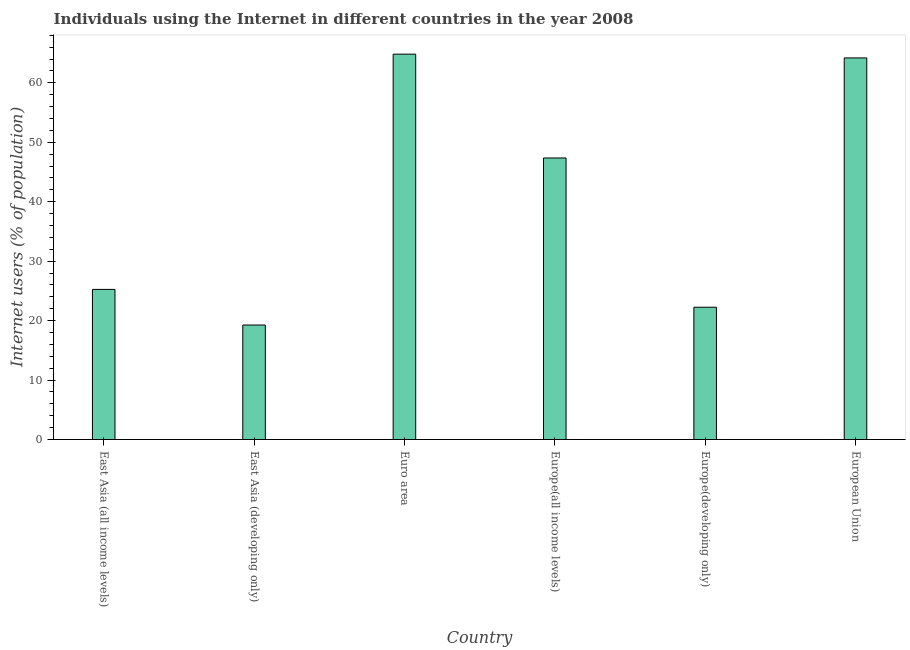Does the graph contain any zero values?
Your response must be concise. No. Does the graph contain grids?
Ensure brevity in your answer.  No. What is the title of the graph?
Ensure brevity in your answer.  Individuals using the Internet in different countries in the year 2008. What is the label or title of the X-axis?
Offer a very short reply. Country. What is the label or title of the Y-axis?
Provide a short and direct response. Internet users (% of population). What is the number of internet users in Euro area?
Give a very brief answer. 64.82. Across all countries, what is the maximum number of internet users?
Offer a terse response. 64.82. Across all countries, what is the minimum number of internet users?
Your answer should be very brief. 19.26. In which country was the number of internet users maximum?
Your response must be concise. Euro area. In which country was the number of internet users minimum?
Your answer should be compact. East Asia (developing only). What is the sum of the number of internet users?
Keep it short and to the point. 243.14. What is the difference between the number of internet users in Europe(developing only) and European Union?
Keep it short and to the point. -41.94. What is the average number of internet users per country?
Give a very brief answer. 40.52. What is the median number of internet users?
Keep it short and to the point. 36.3. In how many countries, is the number of internet users greater than 56 %?
Offer a terse response. 2. What is the ratio of the number of internet users in East Asia (all income levels) to that in Euro area?
Provide a short and direct response. 0.39. Is the number of internet users in Euro area less than that in European Union?
Offer a very short reply. No. Is the difference between the number of internet users in Europe(all income levels) and European Union greater than the difference between any two countries?
Make the answer very short. No. What is the difference between the highest and the second highest number of internet users?
Your response must be concise. 0.64. What is the difference between the highest and the lowest number of internet users?
Keep it short and to the point. 45.56. How many countries are there in the graph?
Your answer should be compact. 6. What is the difference between two consecutive major ticks on the Y-axis?
Ensure brevity in your answer.  10. Are the values on the major ticks of Y-axis written in scientific E-notation?
Offer a very short reply. No. What is the Internet users (% of population) in East Asia (all income levels)?
Your answer should be very brief. 25.25. What is the Internet users (% of population) of East Asia (developing only)?
Keep it short and to the point. 19.26. What is the Internet users (% of population) of Euro area?
Your answer should be very brief. 64.82. What is the Internet users (% of population) of Europe(all income levels)?
Make the answer very short. 47.36. What is the Internet users (% of population) in Europe(developing only)?
Ensure brevity in your answer.  22.25. What is the Internet users (% of population) in European Union?
Offer a terse response. 64.19. What is the difference between the Internet users (% of population) in East Asia (all income levels) and East Asia (developing only)?
Offer a very short reply. 5.99. What is the difference between the Internet users (% of population) in East Asia (all income levels) and Euro area?
Offer a very short reply. -39.57. What is the difference between the Internet users (% of population) in East Asia (all income levels) and Europe(all income levels)?
Provide a succinct answer. -22.1. What is the difference between the Internet users (% of population) in East Asia (all income levels) and Europe(developing only)?
Provide a succinct answer. 3. What is the difference between the Internet users (% of population) in East Asia (all income levels) and European Union?
Make the answer very short. -38.94. What is the difference between the Internet users (% of population) in East Asia (developing only) and Euro area?
Your answer should be compact. -45.56. What is the difference between the Internet users (% of population) in East Asia (developing only) and Europe(all income levels)?
Provide a short and direct response. -28.1. What is the difference between the Internet users (% of population) in East Asia (developing only) and Europe(developing only)?
Ensure brevity in your answer.  -2.99. What is the difference between the Internet users (% of population) in East Asia (developing only) and European Union?
Your answer should be compact. -44.93. What is the difference between the Internet users (% of population) in Euro area and Europe(all income levels)?
Ensure brevity in your answer.  17.47. What is the difference between the Internet users (% of population) in Euro area and Europe(developing only)?
Your answer should be very brief. 42.57. What is the difference between the Internet users (% of population) in Euro area and European Union?
Your answer should be compact. 0.63. What is the difference between the Internet users (% of population) in Europe(all income levels) and Europe(developing only)?
Provide a short and direct response. 25.1. What is the difference between the Internet users (% of population) in Europe(all income levels) and European Union?
Offer a very short reply. -16.83. What is the difference between the Internet users (% of population) in Europe(developing only) and European Union?
Provide a succinct answer. -41.94. What is the ratio of the Internet users (% of population) in East Asia (all income levels) to that in East Asia (developing only)?
Your answer should be very brief. 1.31. What is the ratio of the Internet users (% of population) in East Asia (all income levels) to that in Euro area?
Ensure brevity in your answer.  0.39. What is the ratio of the Internet users (% of population) in East Asia (all income levels) to that in Europe(all income levels)?
Keep it short and to the point. 0.53. What is the ratio of the Internet users (% of population) in East Asia (all income levels) to that in Europe(developing only)?
Provide a short and direct response. 1.14. What is the ratio of the Internet users (% of population) in East Asia (all income levels) to that in European Union?
Your answer should be compact. 0.39. What is the ratio of the Internet users (% of population) in East Asia (developing only) to that in Euro area?
Keep it short and to the point. 0.3. What is the ratio of the Internet users (% of population) in East Asia (developing only) to that in Europe(all income levels)?
Ensure brevity in your answer.  0.41. What is the ratio of the Internet users (% of population) in East Asia (developing only) to that in Europe(developing only)?
Your response must be concise. 0.86. What is the ratio of the Internet users (% of population) in East Asia (developing only) to that in European Union?
Your answer should be compact. 0.3. What is the ratio of the Internet users (% of population) in Euro area to that in Europe(all income levels)?
Make the answer very short. 1.37. What is the ratio of the Internet users (% of population) in Euro area to that in Europe(developing only)?
Keep it short and to the point. 2.91. What is the ratio of the Internet users (% of population) in Euro area to that in European Union?
Give a very brief answer. 1.01. What is the ratio of the Internet users (% of population) in Europe(all income levels) to that in Europe(developing only)?
Ensure brevity in your answer.  2.13. What is the ratio of the Internet users (% of population) in Europe(all income levels) to that in European Union?
Make the answer very short. 0.74. What is the ratio of the Internet users (% of population) in Europe(developing only) to that in European Union?
Make the answer very short. 0.35. 